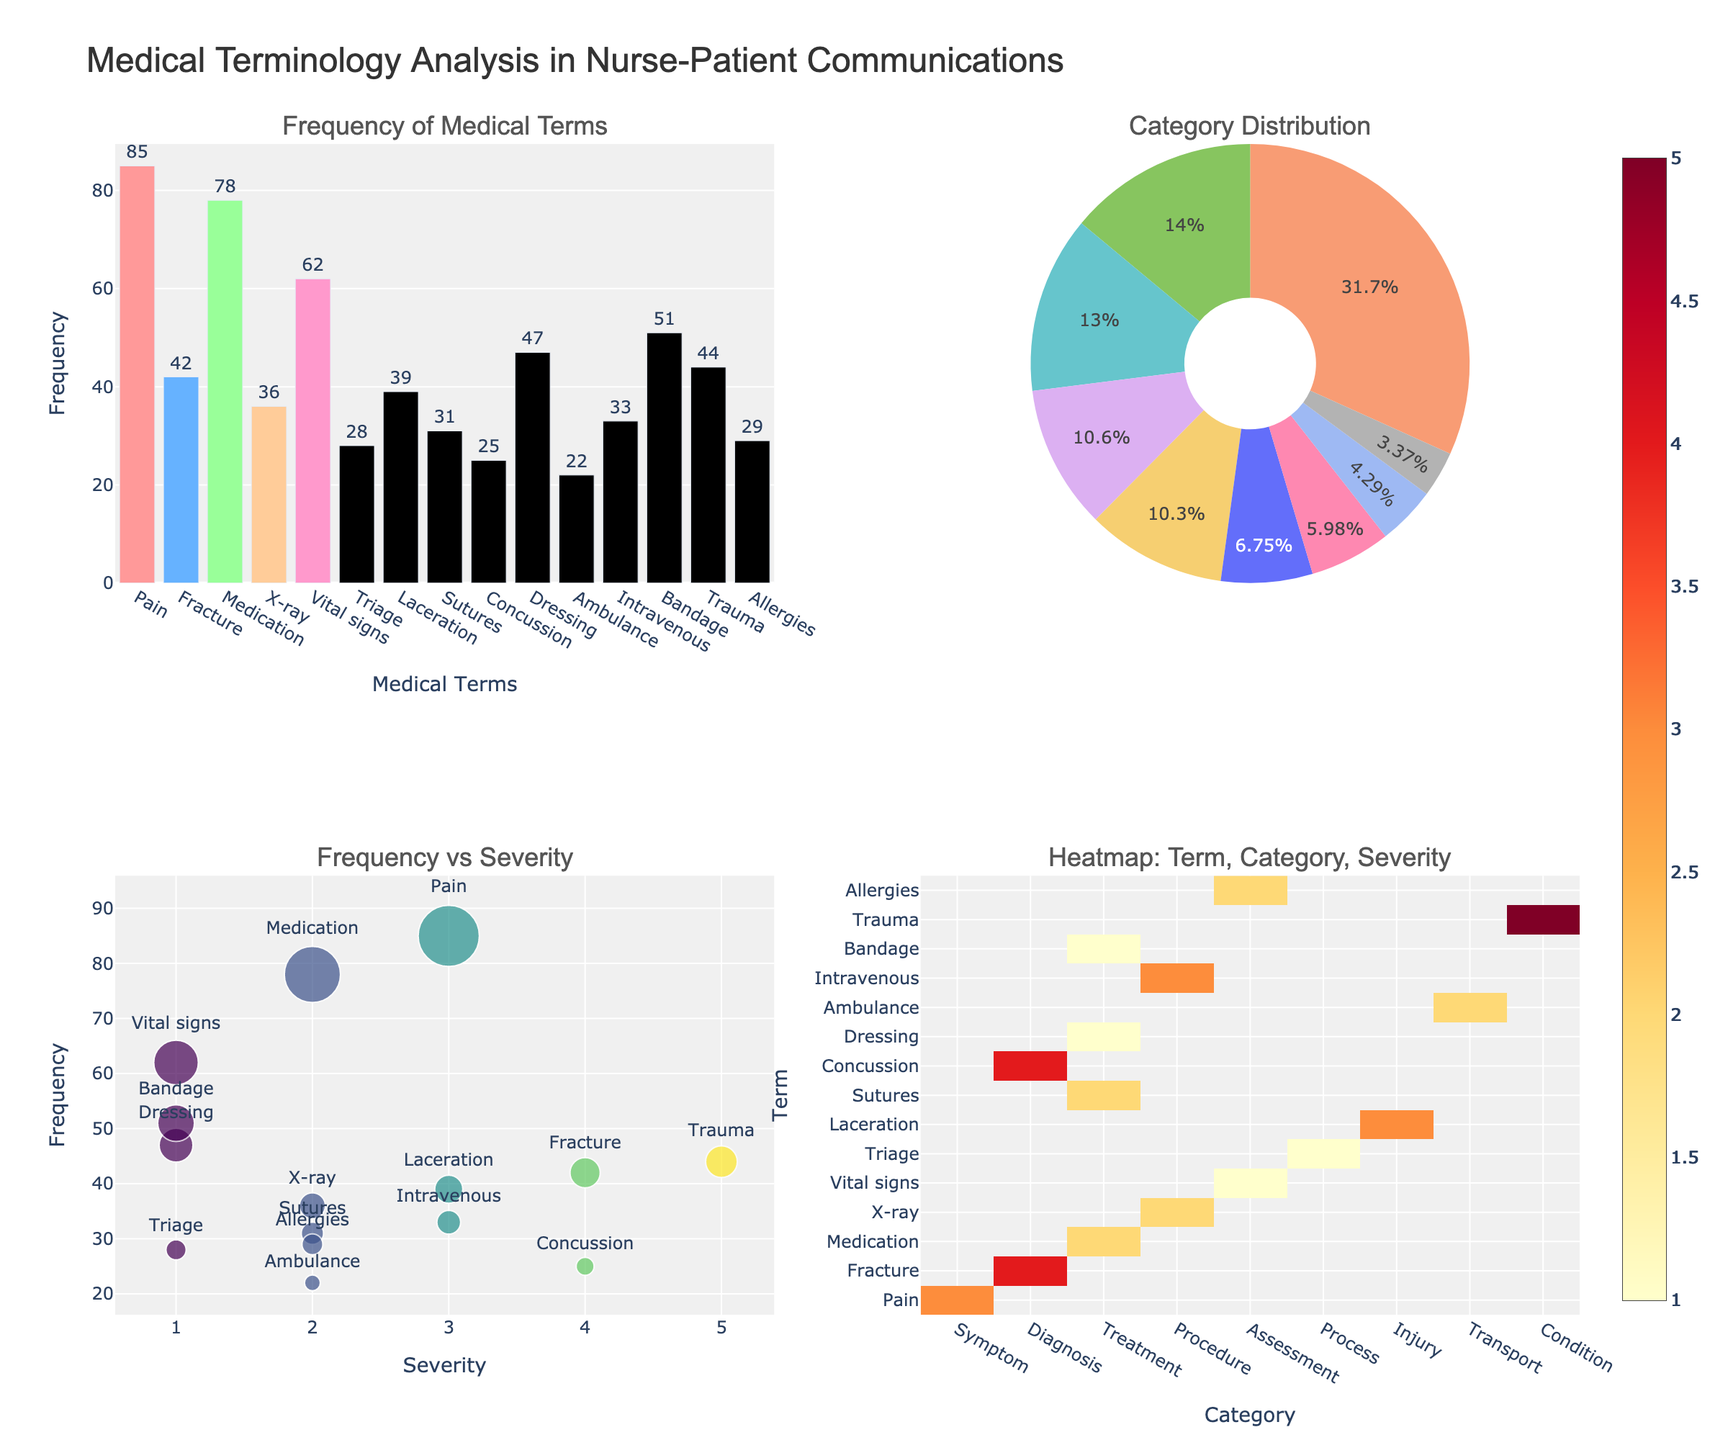What is the highest frequency term? In the bar chart, the tallest bar represents the term with the highest frequency. "Pain" has the highest bar, indicating it is the most frequently mentioned term.
Answer: Pain Which category has the highest proportion of terms? In the pie chart, the largest slice represents the category with the highest proportion. The "Treatment" category has the largest slice.
Answer: Treatment What is the relationship between severity and frequency for 'Trauma'? In the scatter plot, find the point labeled "Trauma". The x-axis is severity and the y-axis is frequency. The point for "Trauma" corresponds to a severity of 5 and a frequency of 44.
Answer: Severity 5, Frequency 44 How many terms are in the 'Assessment' category? In the heatmap, look at the 'Assessment' column on the x-axis. Two terms are plotted under 'Assessment'.
Answer: 2 What is the total frequency of all terms in the 'Diagnosis' category? In the pie chart or heatmap, identify the terms under 'Diagnosis'. They are 'Fracture' and 'Concussion'. Adding up their frequencies: 42 (Fracture) + 25 (Concussion) = 67.
Answer: 67 Which term has the lowest frequency in the bar chart? The shortest bar in the bar chart represents the term with the lowest frequency. "Ambulance" has the shortest bar.
Answer: Ambulance Is there any term with a severity of 3 that has a higher frequency than 'Intravenous'? In the scatter plot, identify terms with severity 3. Compare their frequencies with 'Intravenous' (frequency 33). "Pain" (frequency 85) and "Laceration" (frequency 39) have higher frequencies.
Answer: Yes Which term appears most frequently in the heatmap's 'Injury' category? In the heatmap, look at the 'Injury' column. The term with the highest value in that column is "Laceration" at frequency 39.
Answer: Laceration What are the frequencies of terms in the 'Assessment' category? In the heatmap, the 'Assessment' column has two terms: 'Vital signs' and 'Allergies'. Their frequencies are 62 (Vital signs) and 29 (Allergies).
Answer: 62 and 29 Which term has the highest severity? In the scatter plot, the x-axis represents severity. The term farthest along this axis is "Trauma" with a severity of 5.
Answer: Trauma 